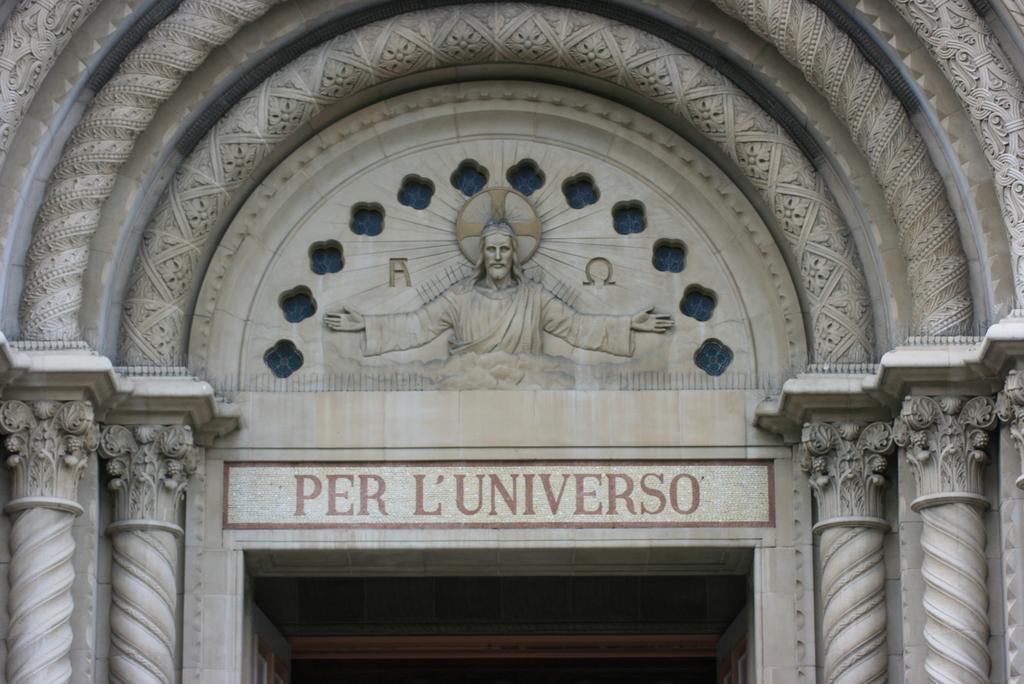Please provide a concise description of this image. In this picture we can see the entrance of a church with pillars and a picture of Jesus at the top. 